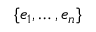<formula> <loc_0><loc_0><loc_500><loc_500>\{ e _ { 1 } , \dots , e _ { n } \}</formula> 